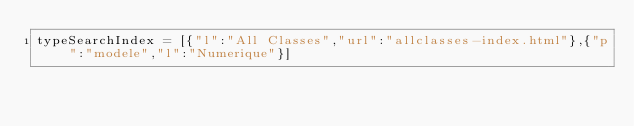<code> <loc_0><loc_0><loc_500><loc_500><_JavaScript_>typeSearchIndex = [{"l":"All Classes","url":"allclasses-index.html"},{"p":"modele","l":"Numerique"}]</code> 